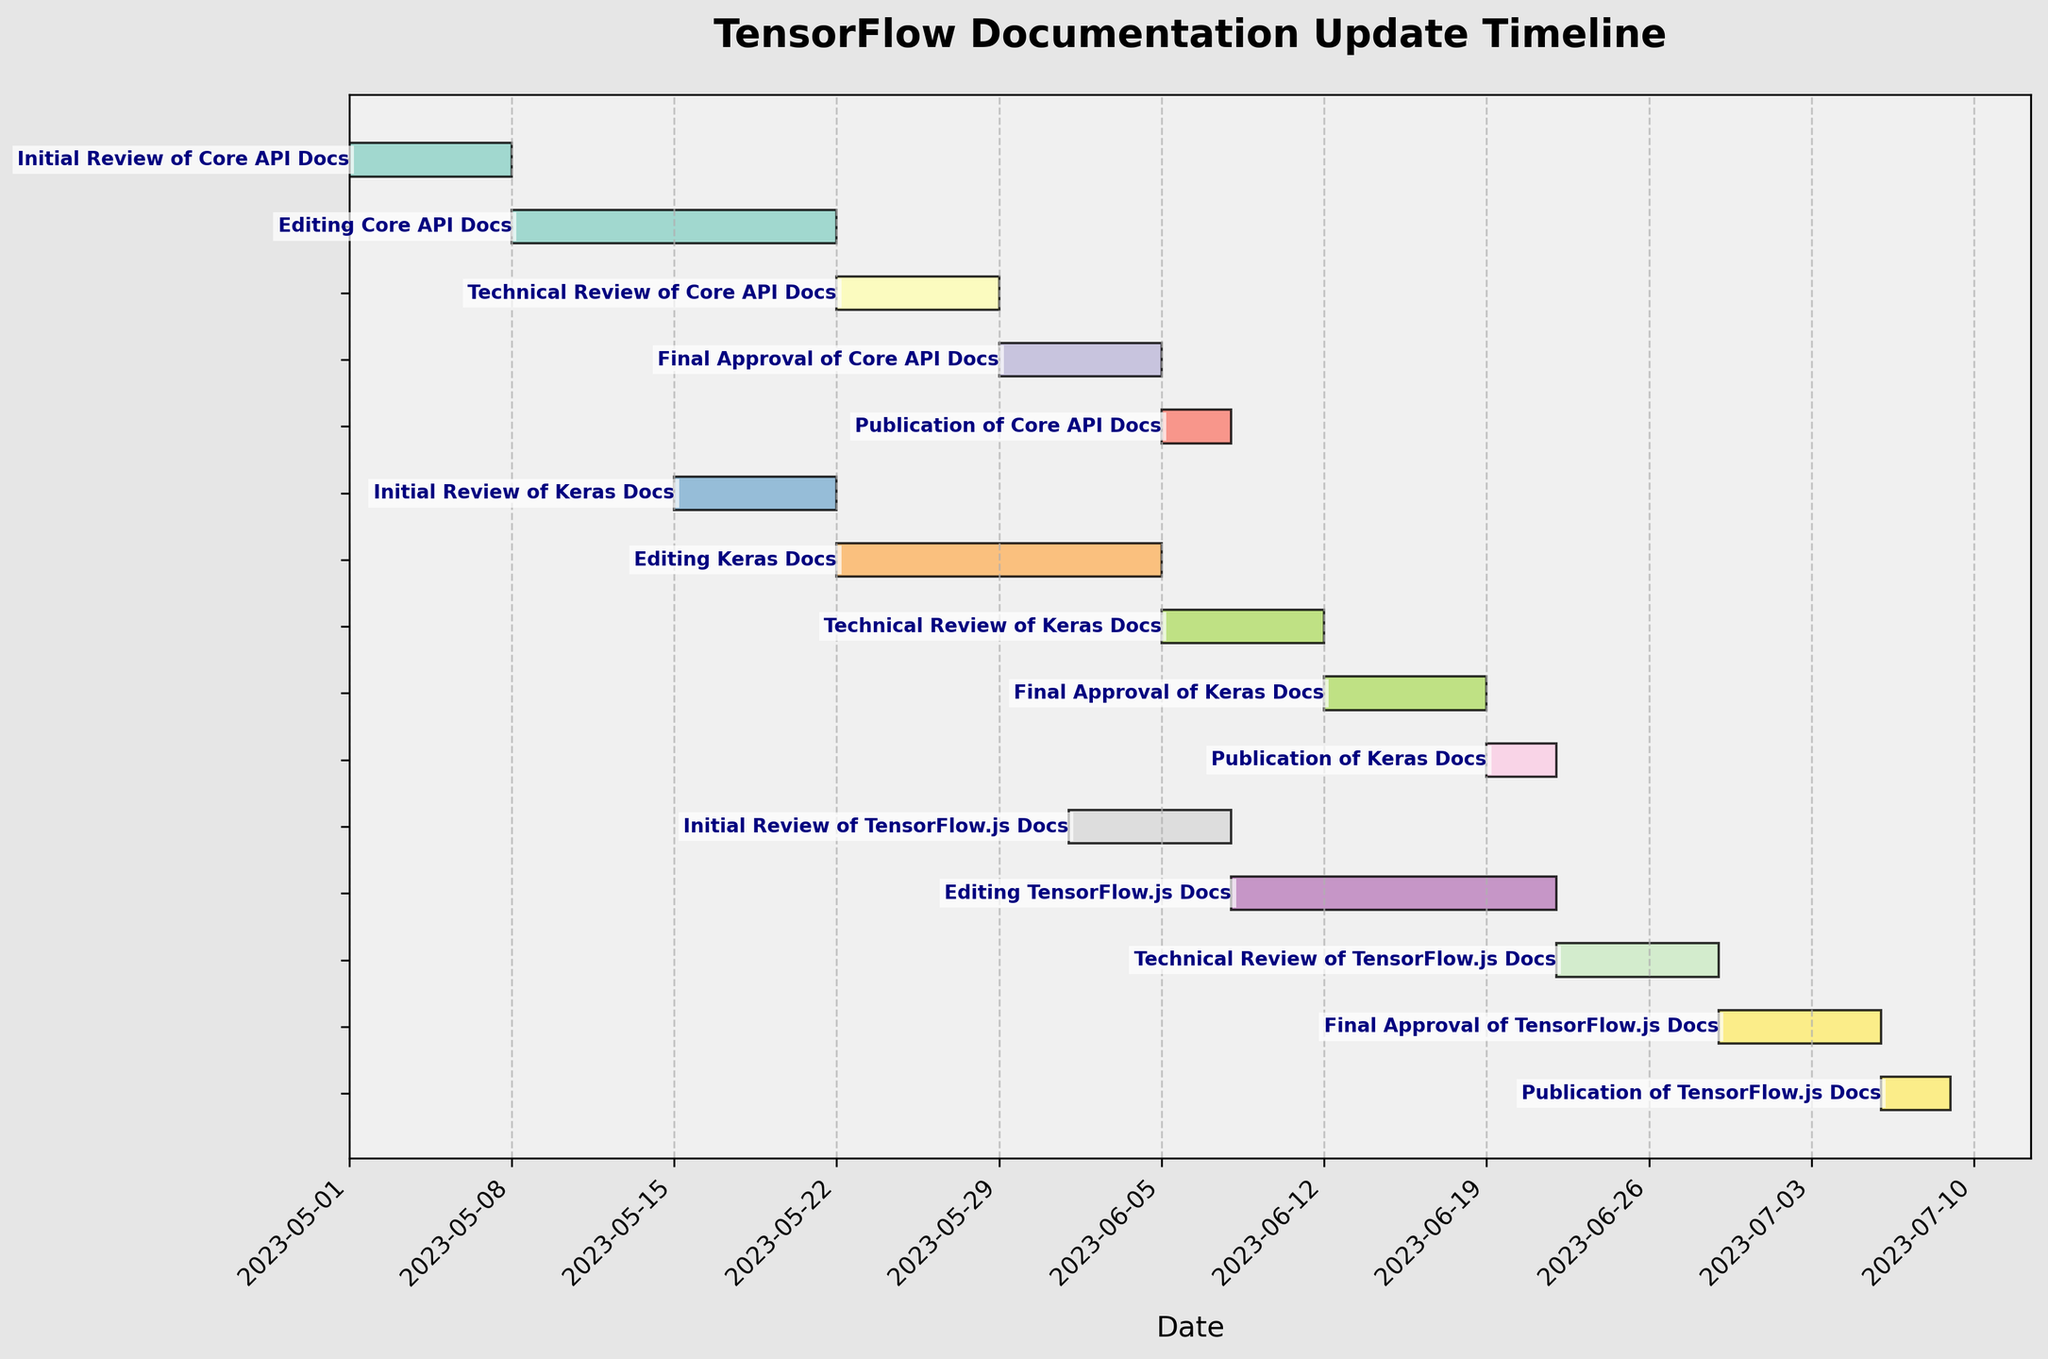What phases are involved in updating the Core API Docs? The phases involved are Initial Review, Editing, Technical Review, Final Approval, and Publication.
Answer: Initial Review, Editing, Technical Review, Final Approval, and Publication What is the title of the Gantt Chart? The title of the Gantt Chart is located at the top of the chart. It reads "TensorFlow Documentation Update Timeline."
Answer: TensorFlow Documentation Update Timeline Which phase for Keras Docs overlaps with the Initial Review of TensorFlow.js Docs? The Initial Review for TensorFlow.js Docs is from June 1 to June 7, and it overlaps with the Editing phase for Keras Docs, which runs from May 22 to June 4.
Answer: Editing What is the duration of the Editing phase for TensorFlow.js Docs? The Editing phase for TensorFlow.js Docs starts on June 8 and ends on June 21. This gives a duration of 14 days.
Answer: 14 days When does the Final Approval of Core API Docs end? The Final Approval of Core API Docs ends on June 4th, as indicated in the timeline.
Answer: June 4 Compare the Publication duration of Core API Docs and Keras Docs. Which task takes longer? The Publication duration of Core API Docs is from June 5 to June 7 (3 days), whereas for Keras Docs it is from June 19 to June 21 (3 days). Both take the same amount of time.
Answer: Both take the same amount of time How many days are there between the end of the Editing phase and the start of the Technical Review phase for Keras Docs? The Editing phase for Keras Docs ends on June 4, and the Technical Review phase starts on June 5. There is a gap of 0 days between these phases.
Answer: 0 days Which task has the longest duration in the process for TensorFlow.js Docs? By visual inspection, the Editing TensorFlow.js Docs task has the longest duration, from June 8 to June 21, which is 14 days.
Answer: Editing TensorFlow.js Docs When do all tasks for updating Keras Docs start and end? All tasks for Keras Docs start with the Initial Review on May 15 and end with the Publication on June 21.
Answer: May 15 to June 21 Does the publication of TensorFlow.js Docs overlap with any other publication phases? The publication of TensorFlow.js Docs from July 6 to July 8 does not overlap with the publication phases of Core API Docs or Keras Docs.
Answer: No 